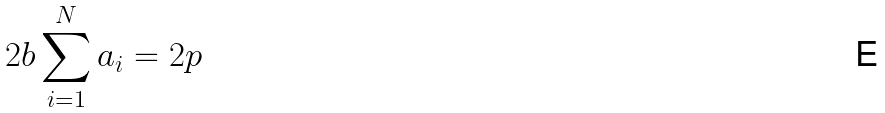<formula> <loc_0><loc_0><loc_500><loc_500>2 b \sum _ { i = 1 } ^ { N } a _ { i } = 2 p</formula> 